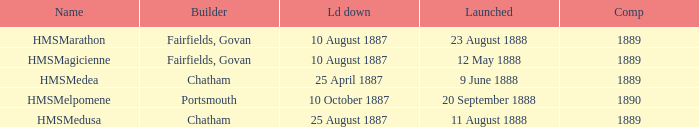What boat was laid down on 25 april 1887? HMSMedea. Could you parse the entire table? {'header': ['Name', 'Builder', 'Ld down', 'Launched', 'Comp'], 'rows': [['HMSMarathon', 'Fairfields, Govan', '10 August 1887', '23 August 1888', '1889'], ['HMSMagicienne', 'Fairfields, Govan', '10 August 1887', '12 May 1888', '1889'], ['HMSMedea', 'Chatham', '25 April 1887', '9 June 1888', '1889'], ['HMSMelpomene', 'Portsmouth', '10 October 1887', '20 September 1888', '1890'], ['HMSMedusa', 'Chatham', '25 August 1887', '11 August 1888', '1889']]} 